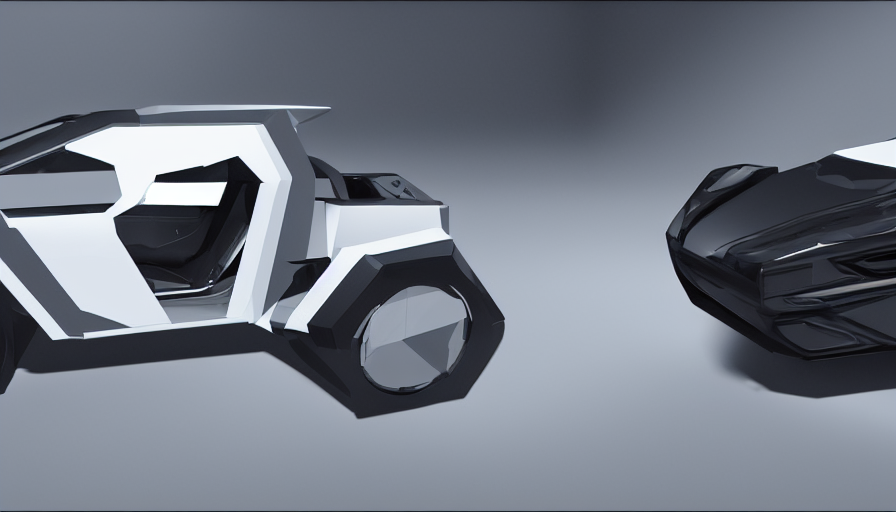Are the fine details and texture clear in the image?
A. Textured elements are not distinguishable
B. Blurred details and texture
C. Yes, the fine details and texture are clear.
Answer with the option's letter from the given choices directly.
 C. 